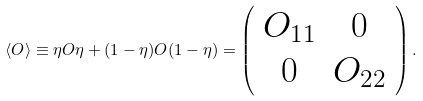Convert formula to latex. <formula><loc_0><loc_0><loc_500><loc_500>\langle O \rangle \equiv \eta O \eta + ( 1 - \eta ) O ( 1 - \eta ) = \left ( \begin{array} { c c } { { O _ { 1 1 } } } & { 0 } \\ { 0 } & { { O _ { 2 2 } } } \end{array} \right ) .</formula> 